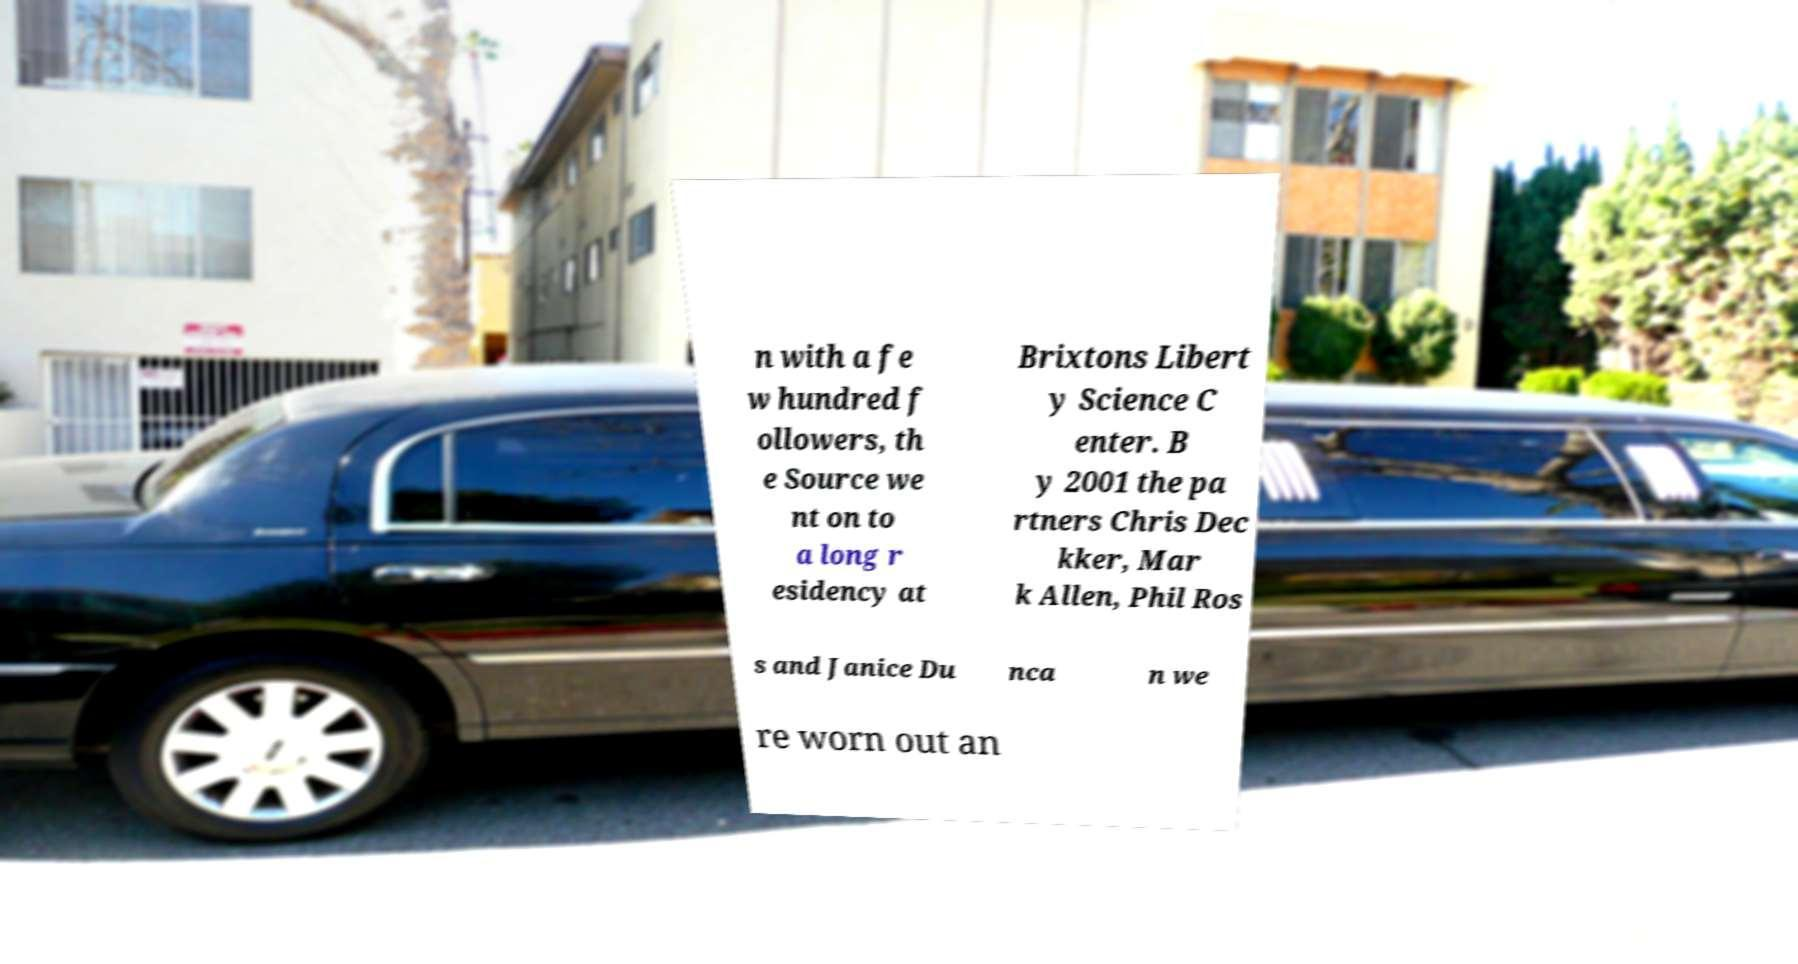Can you read and provide the text displayed in the image?This photo seems to have some interesting text. Can you extract and type it out for me? n with a fe w hundred f ollowers, th e Source we nt on to a long r esidency at Brixtons Libert y Science C enter. B y 2001 the pa rtners Chris Dec kker, Mar k Allen, Phil Ros s and Janice Du nca n we re worn out an 